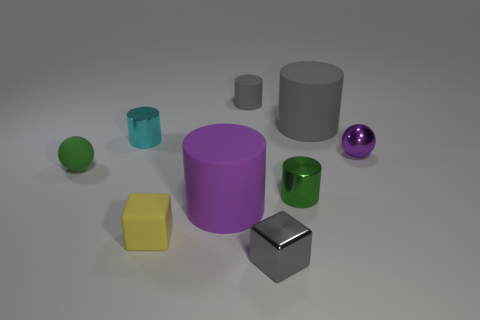How does the purple sphere compare in size to the other objects? The purple sphere is comparable in size to the cyan cylinder and the green mug, but it is larger than the smaller green sphere and the grey cylinder. It is, however, smaller than the larger purple cylinder. 